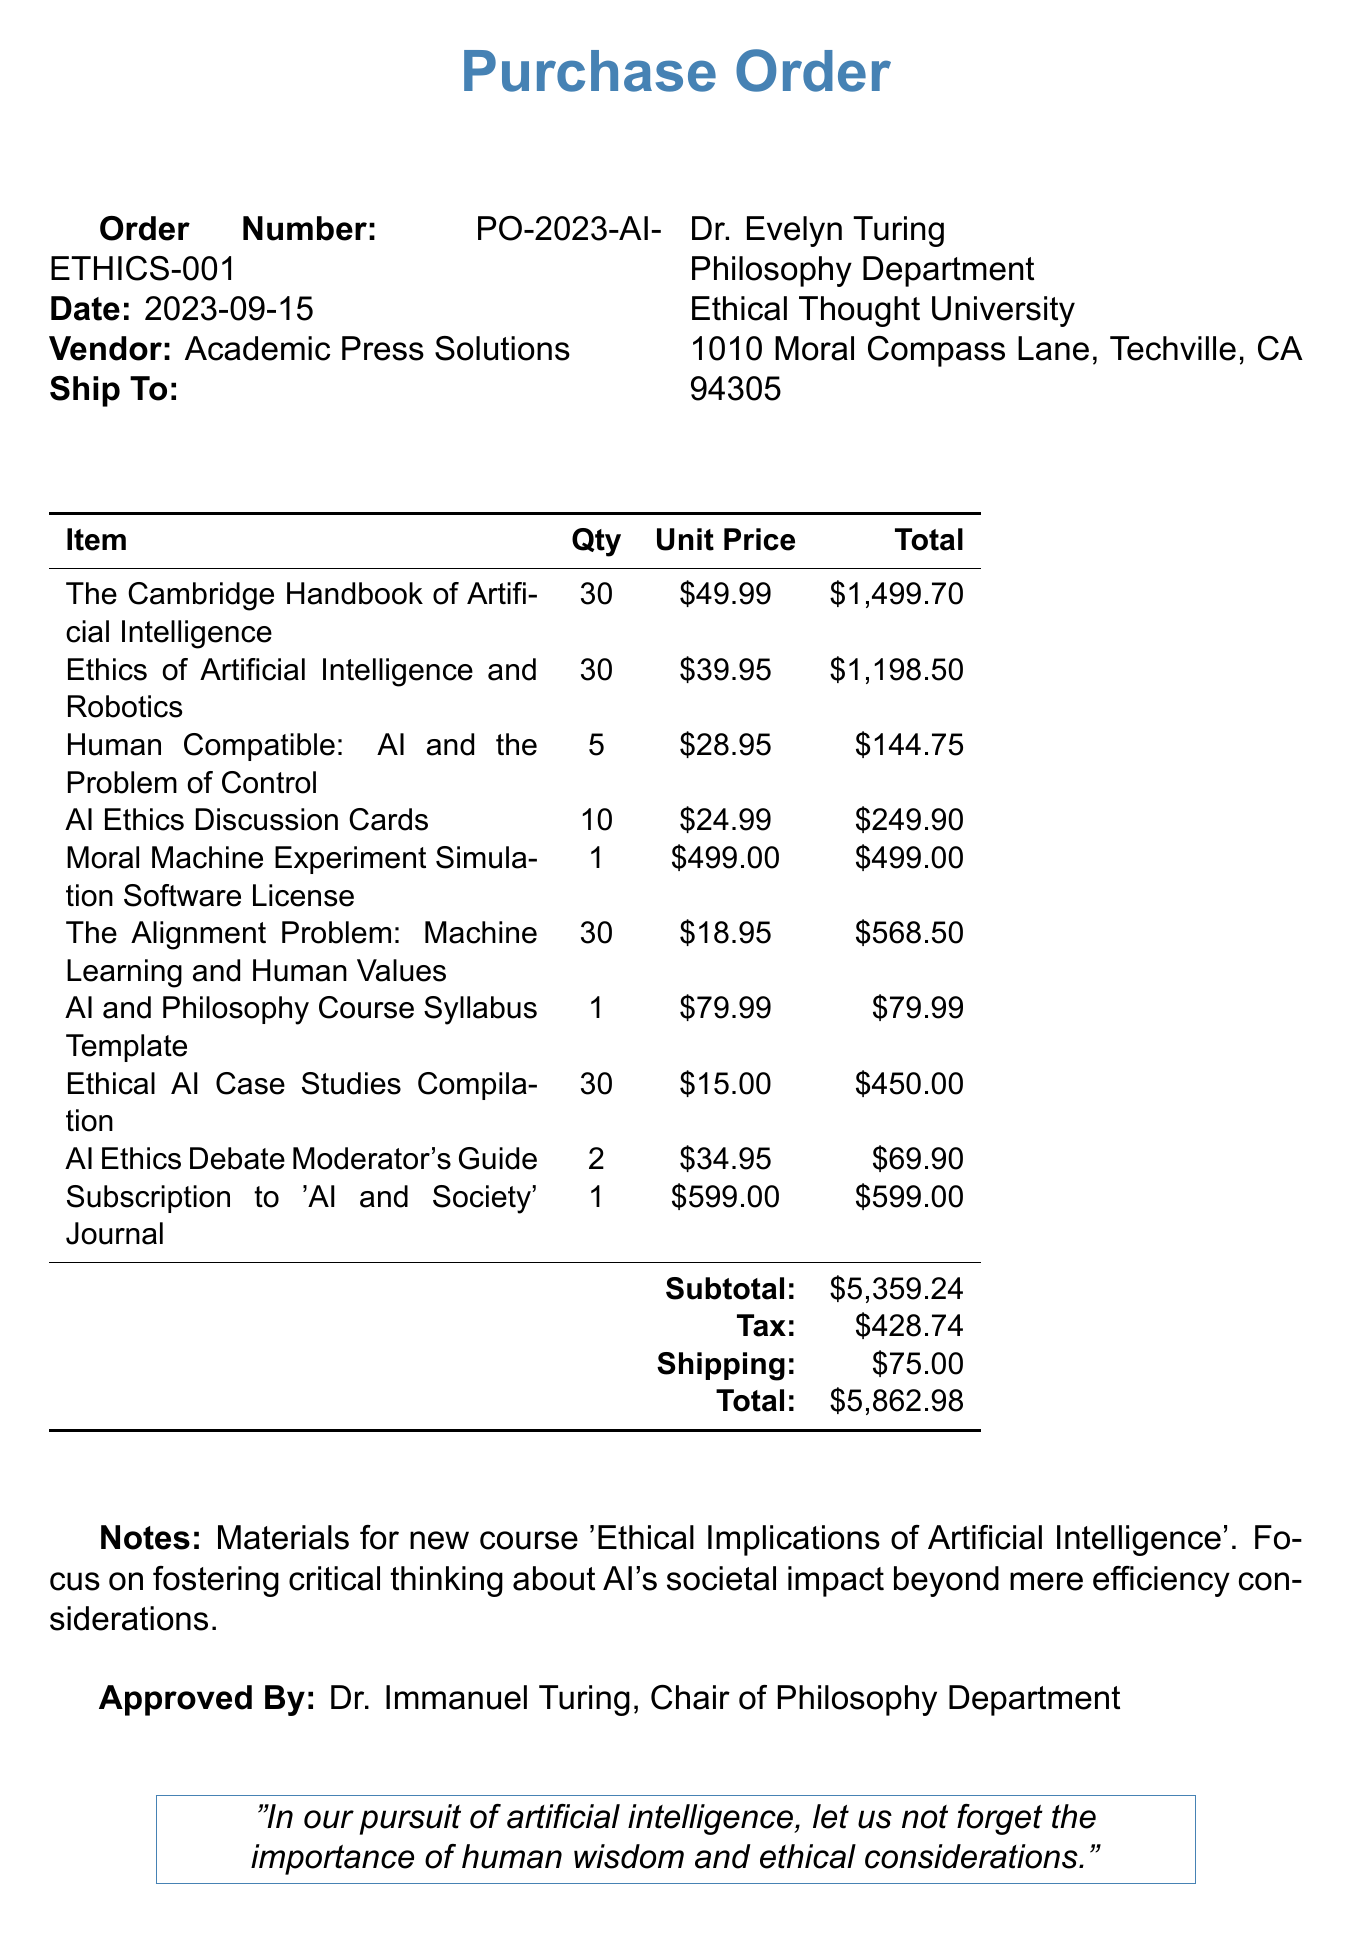What is the order number? The order number is specified in the document as a unique identifier for the transaction, which is PO-2023-AI-ETHICS-001.
Answer: PO-2023-AI-ETHICS-001 Who is the vendor? The vendor is the company from which the materials are purchased, noted as Academic Press Solutions.
Answer: Academic Press Solutions What is the total amount of the purchase order? The total amount is calculated after taking into account the subtotal, tax, and shipping, stated as 5862.98.
Answer: 5862.98 How many copies of "The Alignment Problem" were ordered? The quantity ordered is mentioned in the item list for "The Alignment Problem: Machine Learning and Human Values", which is 30.
Answer: 30 What is stated in the notes section? The notes provide context for the order, indicating that it is for a new course focusing on critical thinking about AI's societal impact beyond efficiency.
Answer: Materials for new course 'Ethical Implications of Artificial Intelligence'. Focus on fostering critical thinking about AI's societal impact beyond mere efficiency considerations Who approved the purchase order? The document specifies who approved the order, which is Dr. Immanuel Turing, noted as the Chair of the Philosophy Department.
Answer: Dr. Immanuel Turing What is the shipping cost? The shipping cost is detailed in the table of costs within the document, specified as 75.00.
Answer: 75.00 Which item has the highest unit price? The highest unit price can be found by comparing the unit prices of all listed items; it is noted as 599.00 for the subscription to 'AI and Society' Journal.
Answer: 599.00 What is the quantity of "AI Ethics Discussion Cards"? The quantity is indicated in the item list for "AI Ethics Discussion Cards", which is 10.
Answer: 10 